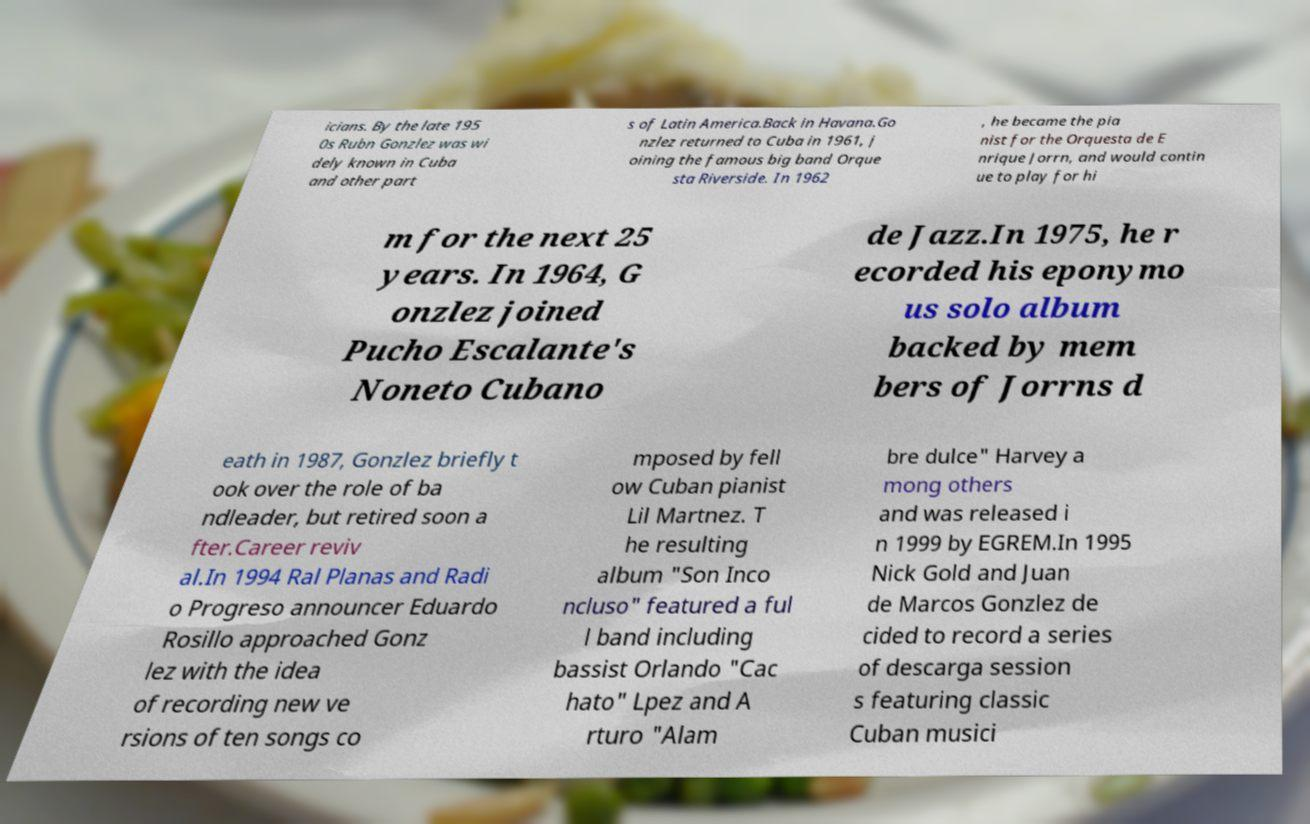Can you accurately transcribe the text from the provided image for me? icians. By the late 195 0s Rubn Gonzlez was wi dely known in Cuba and other part s of Latin America.Back in Havana.Go nzlez returned to Cuba in 1961, j oining the famous big band Orque sta Riverside. In 1962 , he became the pia nist for the Orquesta de E nrique Jorrn, and would contin ue to play for hi m for the next 25 years. In 1964, G onzlez joined Pucho Escalante's Noneto Cubano de Jazz.In 1975, he r ecorded his eponymo us solo album backed by mem bers of Jorrns d eath in 1987, Gonzlez briefly t ook over the role of ba ndleader, but retired soon a fter.Career reviv al.In 1994 Ral Planas and Radi o Progreso announcer Eduardo Rosillo approached Gonz lez with the idea of recording new ve rsions of ten songs co mposed by fell ow Cuban pianist Lil Martnez. T he resulting album "Son Inco ncluso" featured a ful l band including bassist Orlando "Cac hato" Lpez and A rturo "Alam bre dulce" Harvey a mong others and was released i n 1999 by EGREM.In 1995 Nick Gold and Juan de Marcos Gonzlez de cided to record a series of descarga session s featuring classic Cuban musici 